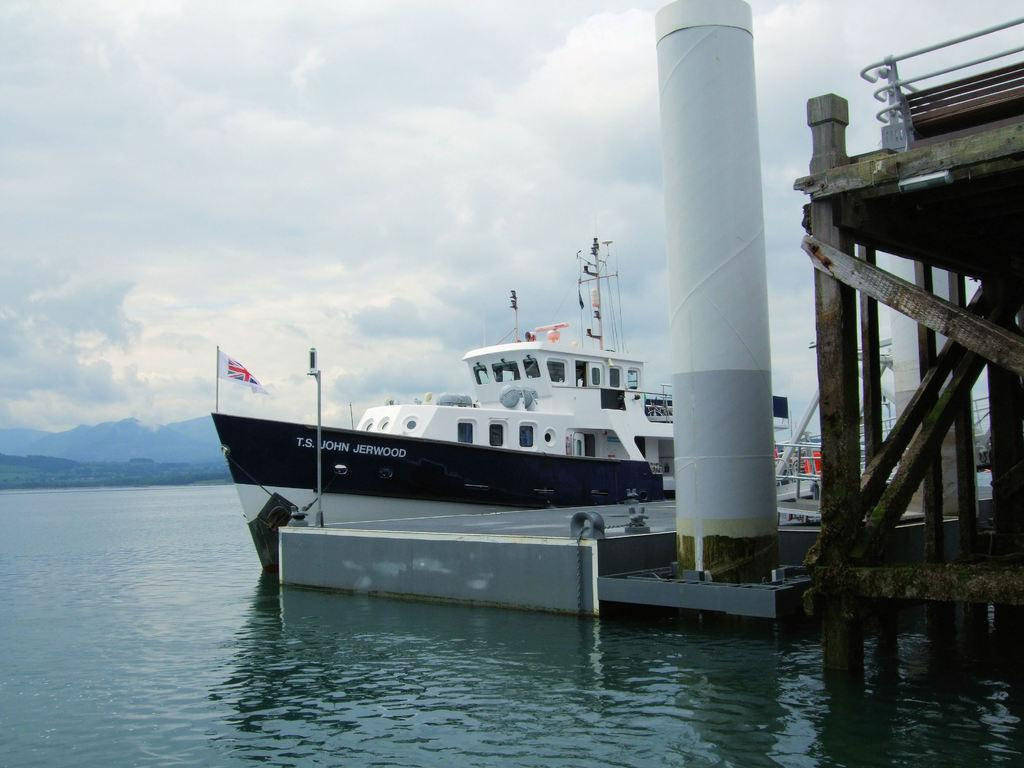Provide a one-sentence caption for the provided image. A ferry boat named T.S. John Jerwood sits at the port in calm river waters. 